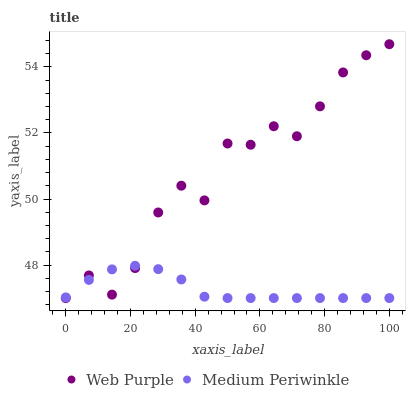Does Medium Periwinkle have the minimum area under the curve?
Answer yes or no. Yes. Does Web Purple have the maximum area under the curve?
Answer yes or no. Yes. Does Medium Periwinkle have the maximum area under the curve?
Answer yes or no. No. Is Medium Periwinkle the smoothest?
Answer yes or no. Yes. Is Web Purple the roughest?
Answer yes or no. Yes. Is Medium Periwinkle the roughest?
Answer yes or no. No. Does Web Purple have the lowest value?
Answer yes or no. Yes. Does Web Purple have the highest value?
Answer yes or no. Yes. Does Medium Periwinkle have the highest value?
Answer yes or no. No. Does Web Purple intersect Medium Periwinkle?
Answer yes or no. Yes. Is Web Purple less than Medium Periwinkle?
Answer yes or no. No. Is Web Purple greater than Medium Periwinkle?
Answer yes or no. No. 